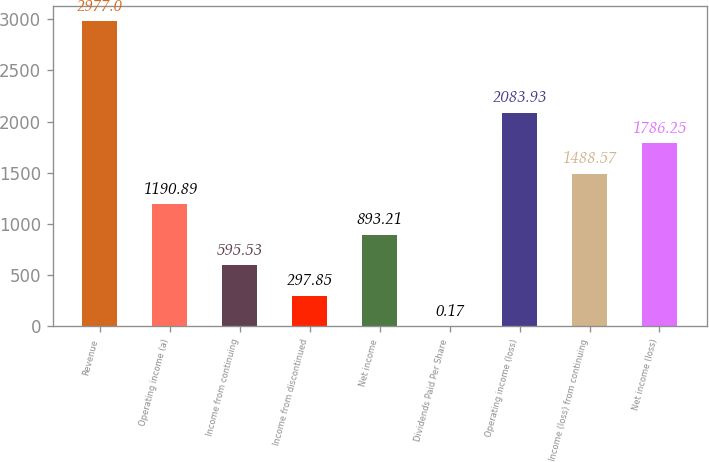Convert chart to OTSL. <chart><loc_0><loc_0><loc_500><loc_500><bar_chart><fcel>Revenue<fcel>Operating income (a)<fcel>Income from continuing<fcel>Income from discontinued<fcel>Net income<fcel>Dividends Paid Per Share<fcel>Operating income (loss)<fcel>Income (loss) from continuing<fcel>Net income (loss)<nl><fcel>2977<fcel>1190.89<fcel>595.53<fcel>297.85<fcel>893.21<fcel>0.17<fcel>2083.93<fcel>1488.57<fcel>1786.25<nl></chart> 